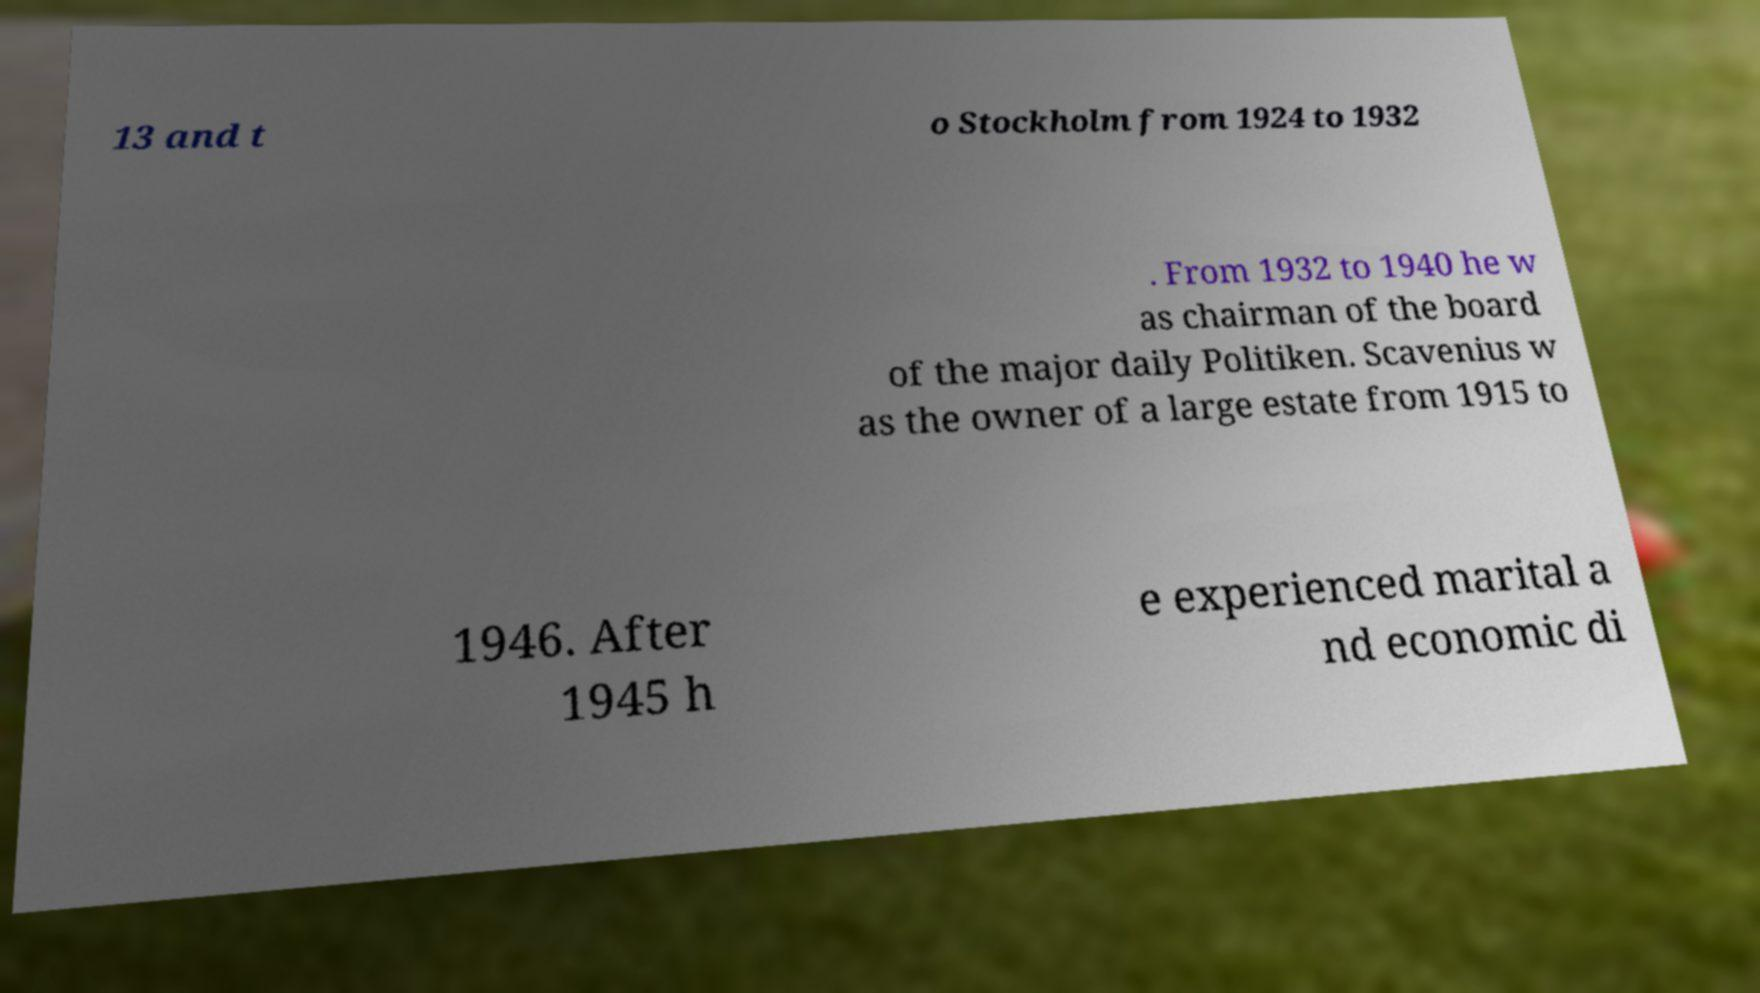Could you assist in decoding the text presented in this image and type it out clearly? 13 and t o Stockholm from 1924 to 1932 . From 1932 to 1940 he w as chairman of the board of the major daily Politiken. Scavenius w as the owner of a large estate from 1915 to 1946. After 1945 h e experienced marital a nd economic di 